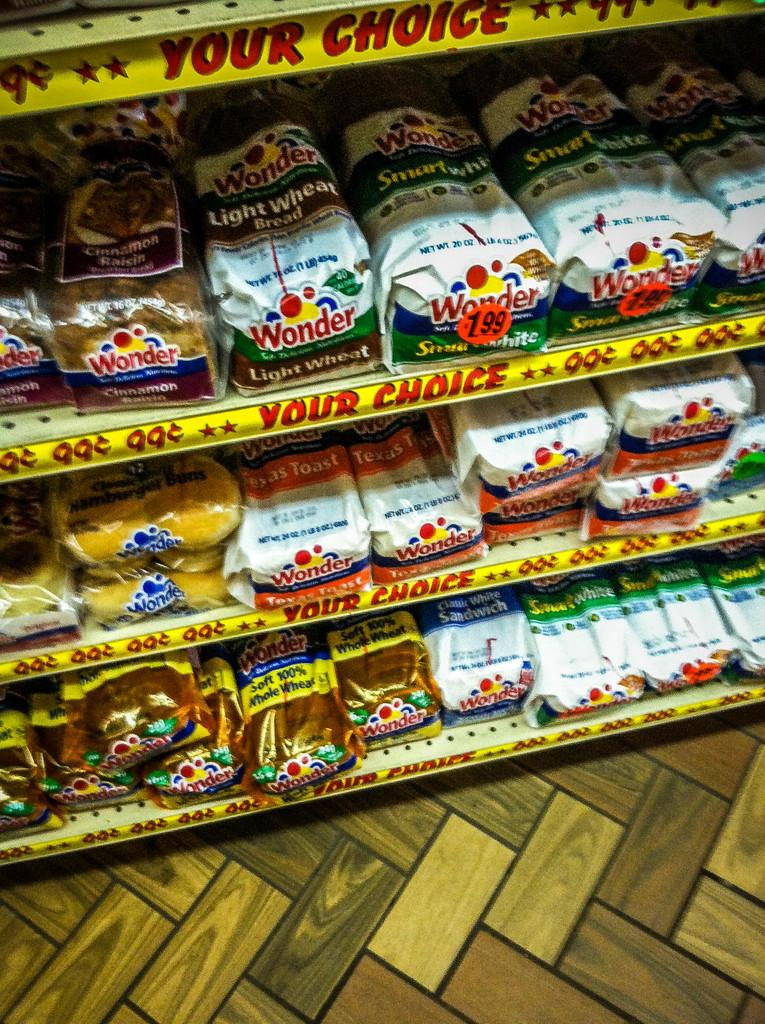<image>
Relay a brief, clear account of the picture shown. Store shelving with the banner "Your Choice" along each shelf holding different varieties of Wonder bread. 